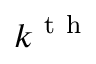Convert formula to latex. <formula><loc_0><loc_0><loc_500><loc_500>k ^ { t h }</formula> 